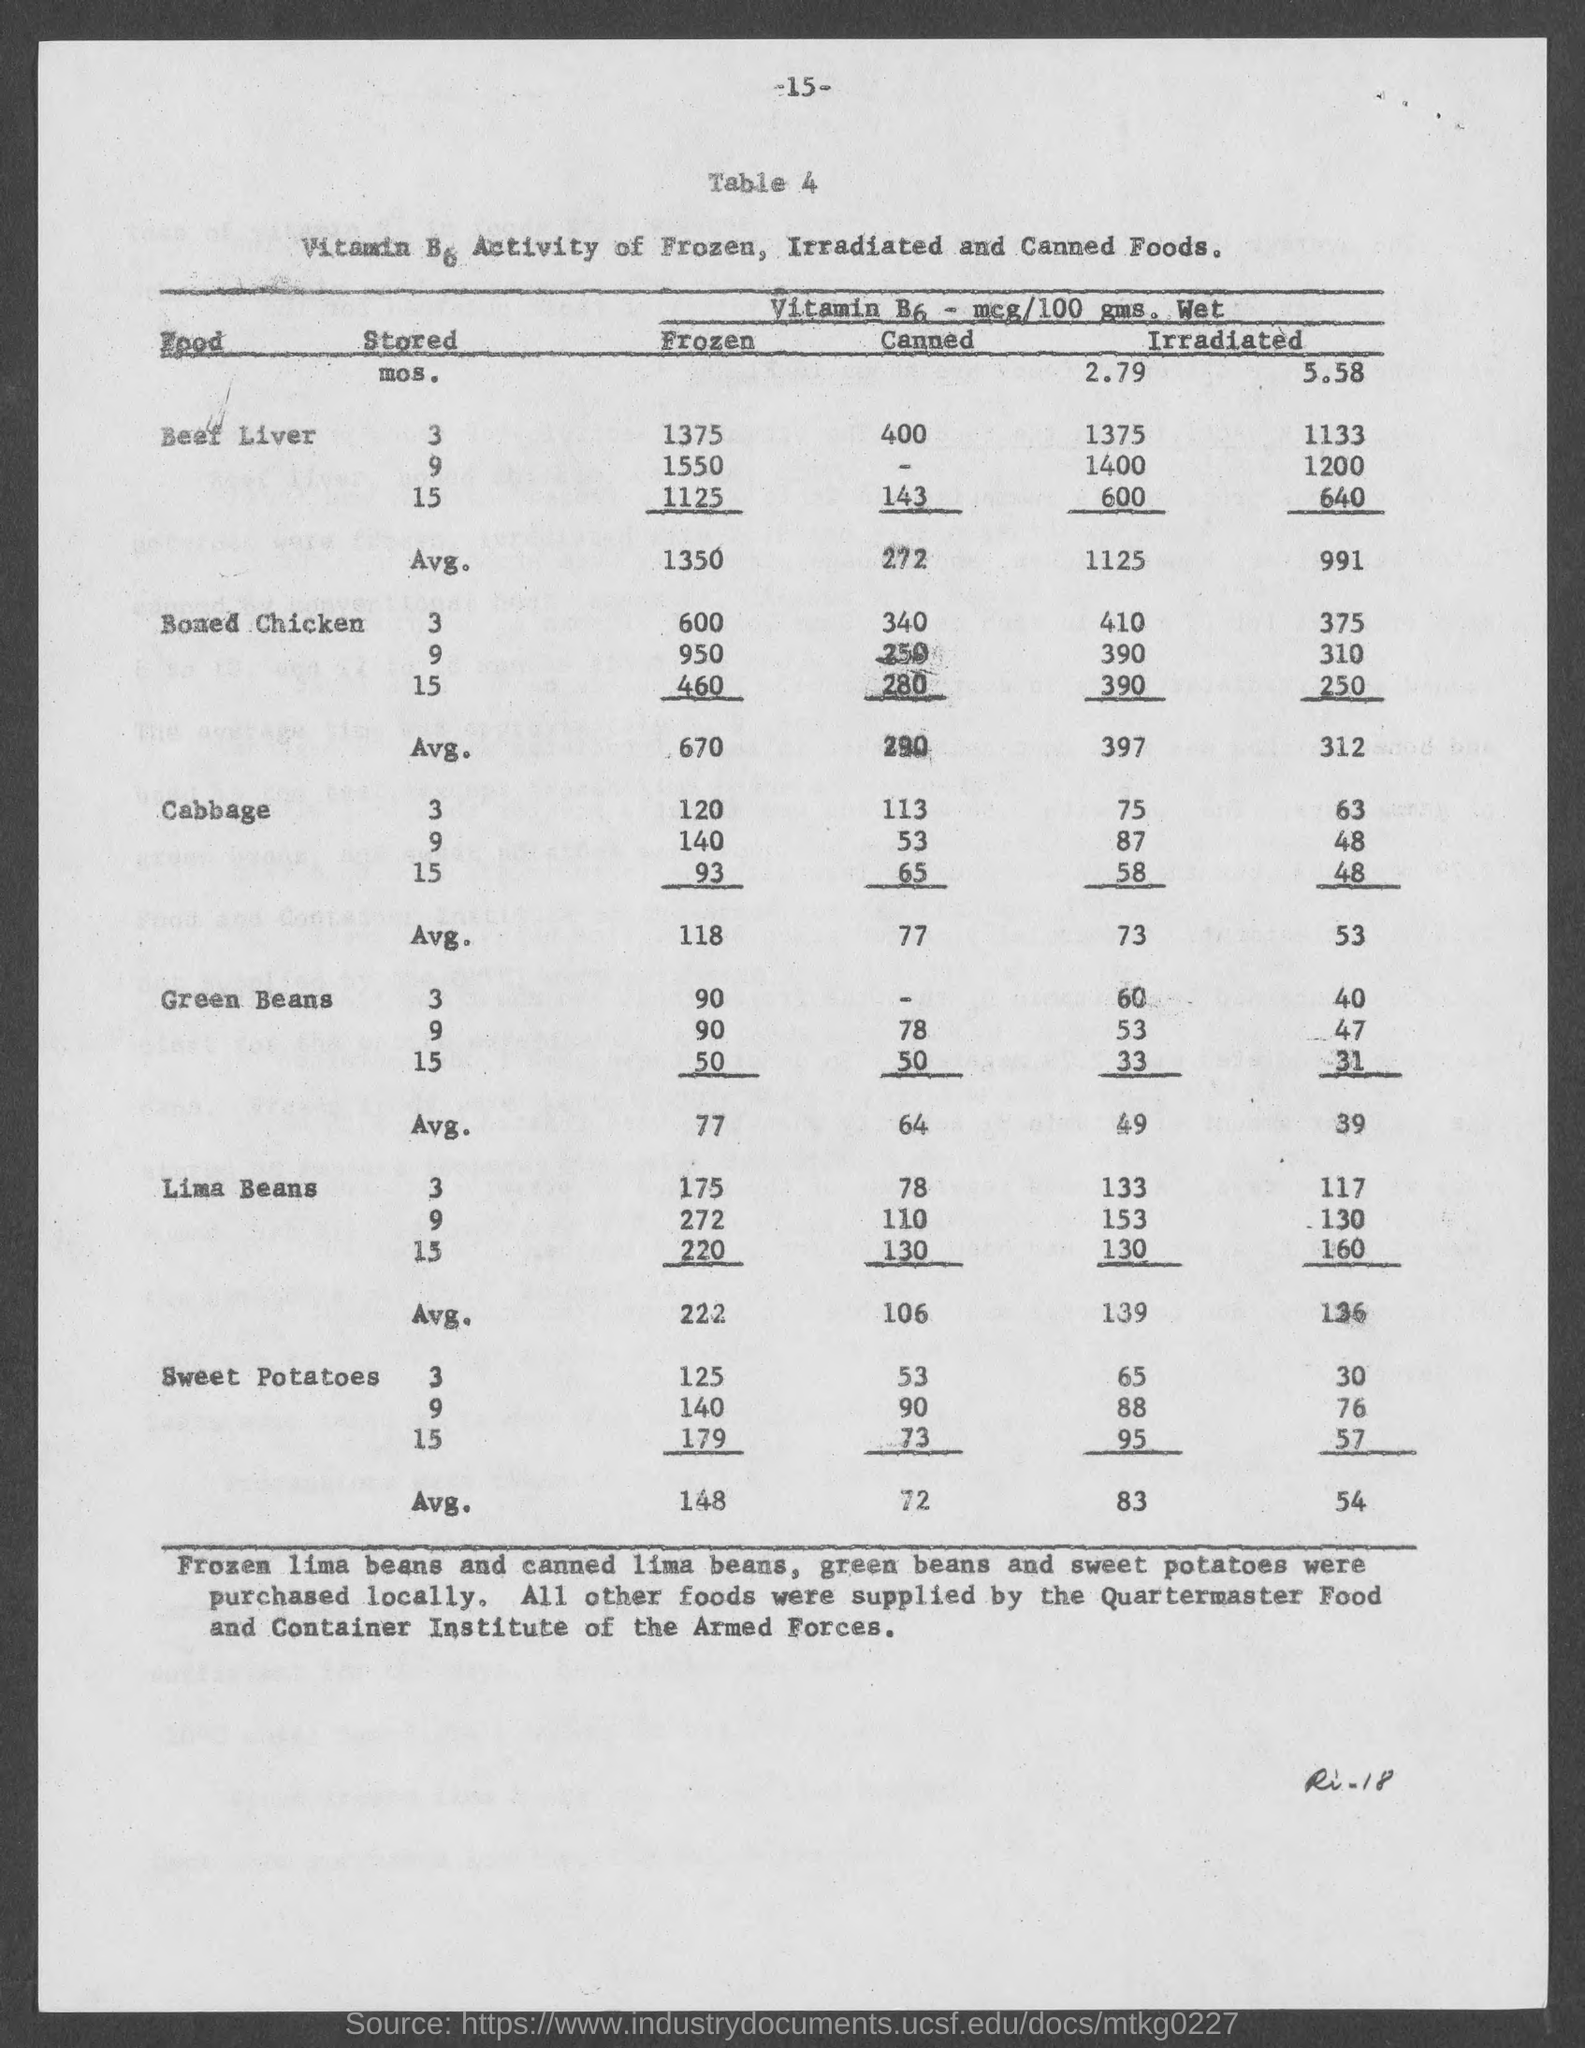What is the Avg. of Frozen Beef Liver ?
Your response must be concise. 1350. What is the Average of Canned Beef Liver ?
Provide a short and direct response. 272. What is the Average of Frozen Boned Chicken ?
Your response must be concise. 670. What is the Average of Canned Boned Chicken ?
Offer a very short reply. 290. What is the Average of Frozen Cabbage ?
Offer a very short reply. 118. What is the Average of Canned Cabbage ?
Ensure brevity in your answer.  77. 